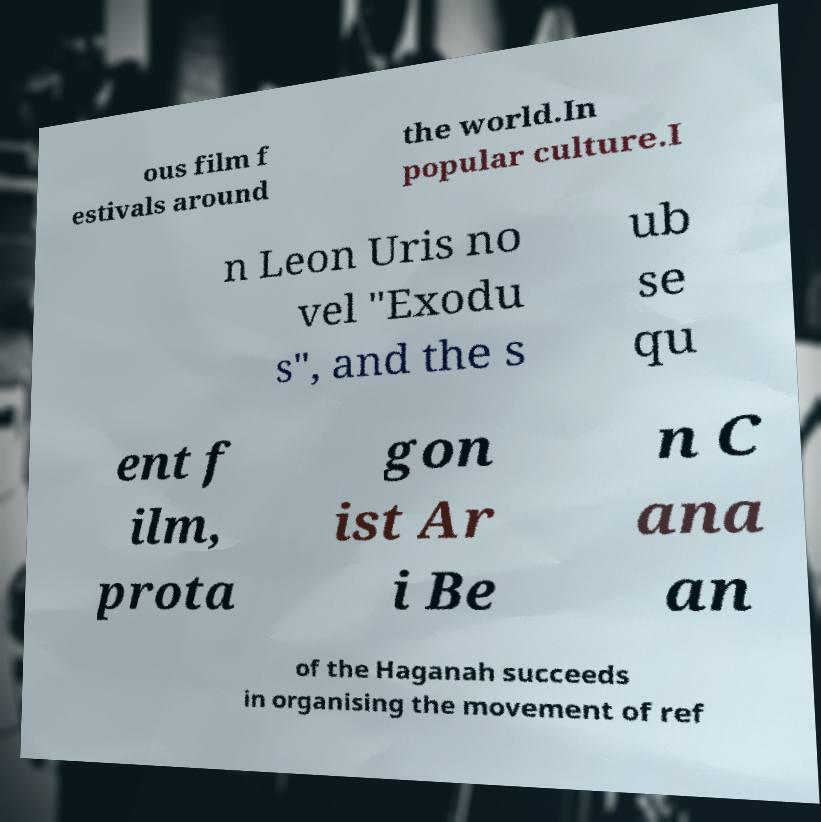Please read and relay the text visible in this image. What does it say? ous film f estivals around the world.In popular culture.I n Leon Uris no vel "Exodu s", and the s ub se qu ent f ilm, prota gon ist Ar i Be n C ana an of the Haganah succeeds in organising the movement of ref 